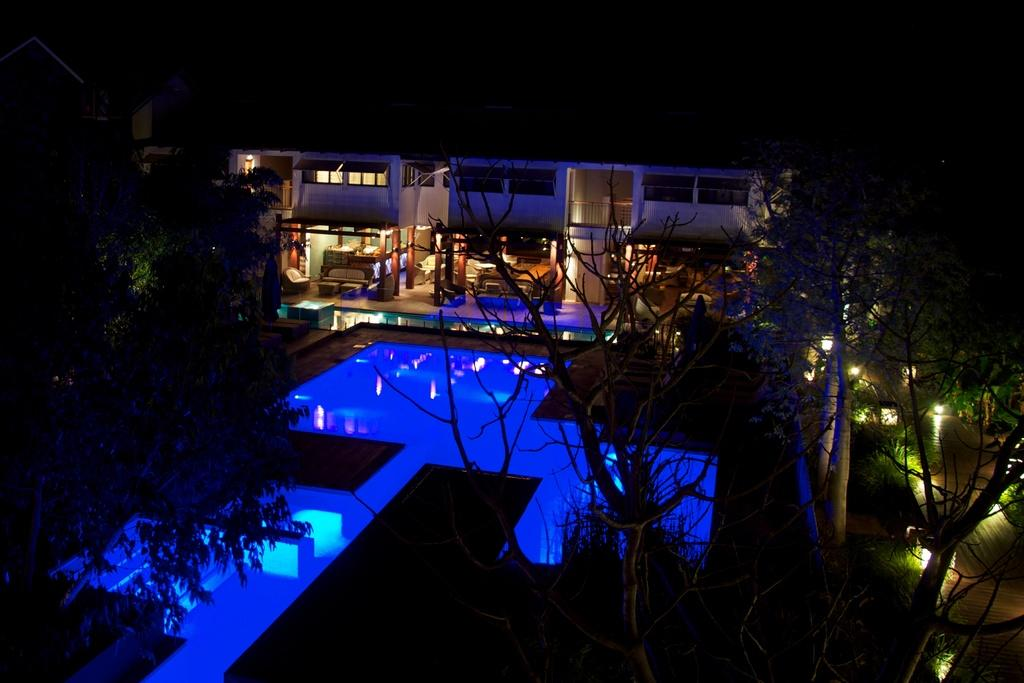What type of structure is visible in the image? There is a building in the image. What is located in front of the building? There is a swimming pool in front of the building. What can be seen on either side of the swimming pool? Trees are present on either side of the swimming pool. What time of day was the image taken? The image was taken at night time. What type of cushion is floating in the swimming pool? There is no cushion present in the swimming pool in the image. What material is the wool used for in the image? There is no wool present in the image. 